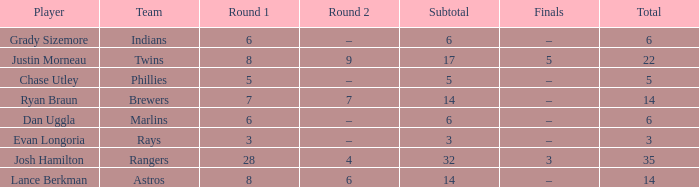Which player has a subtotal of more than 3 and more than 8 in round 1? Josh Hamilton. 